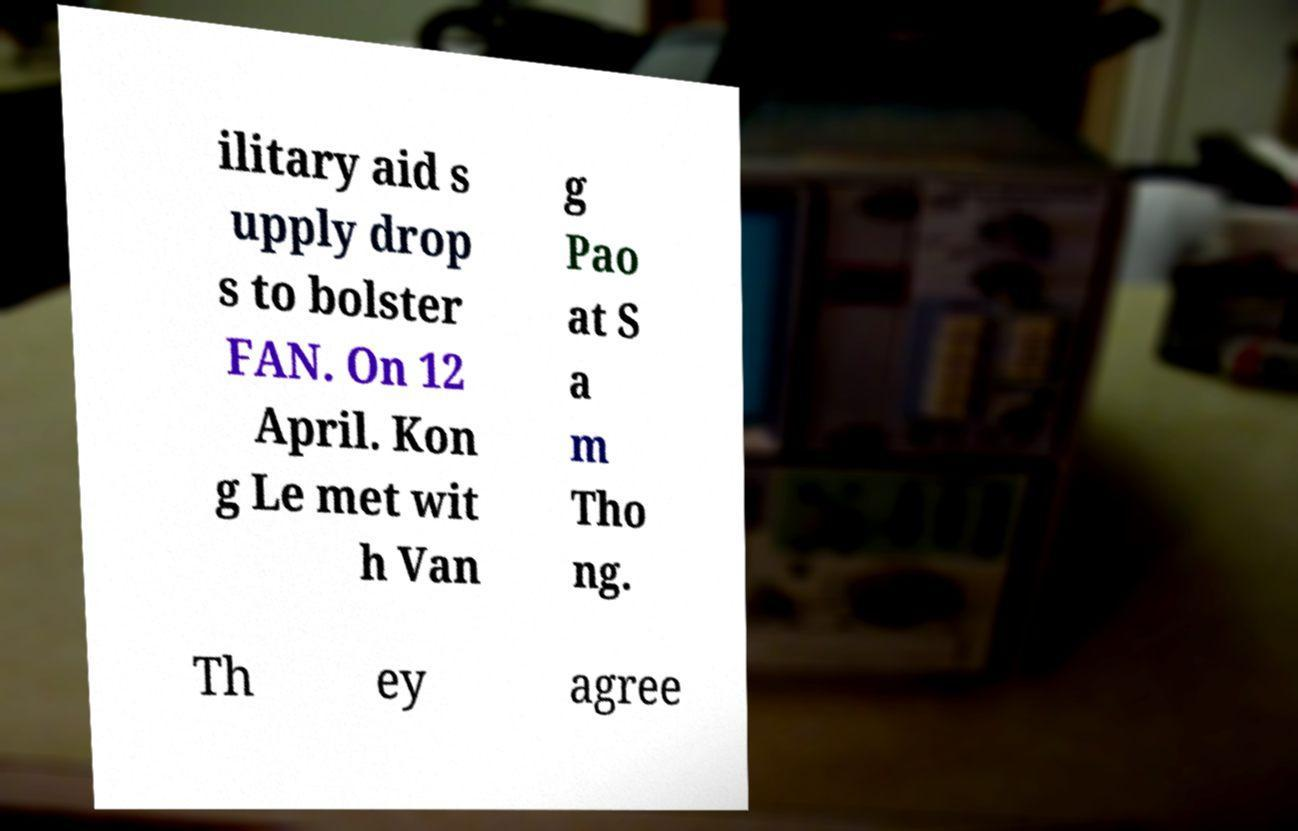I need the written content from this picture converted into text. Can you do that? ilitary aid s upply drop s to bolster FAN. On 12 April. Kon g Le met wit h Van g Pao at S a m Tho ng. Th ey agree 